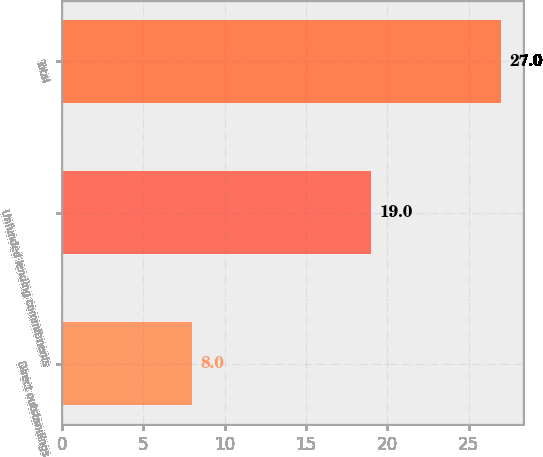<chart> <loc_0><loc_0><loc_500><loc_500><bar_chart><fcel>Direct outstandings<fcel>Unfunded lending commitments<fcel>Total<nl><fcel>8<fcel>19<fcel>27<nl></chart> 